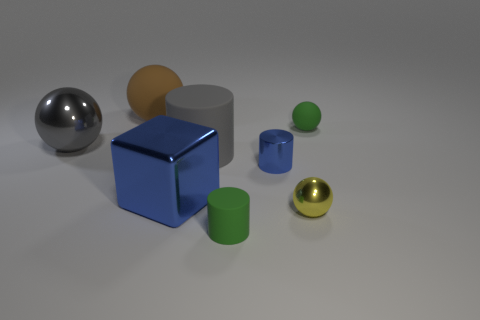Add 1 large red rubber cubes. How many objects exist? 9 Subtract all blocks. How many objects are left? 7 Subtract 1 green balls. How many objects are left? 7 Subtract all red cylinders. Subtract all tiny blue objects. How many objects are left? 7 Add 4 brown matte things. How many brown matte things are left? 5 Add 5 big shiny blocks. How many big shiny blocks exist? 6 